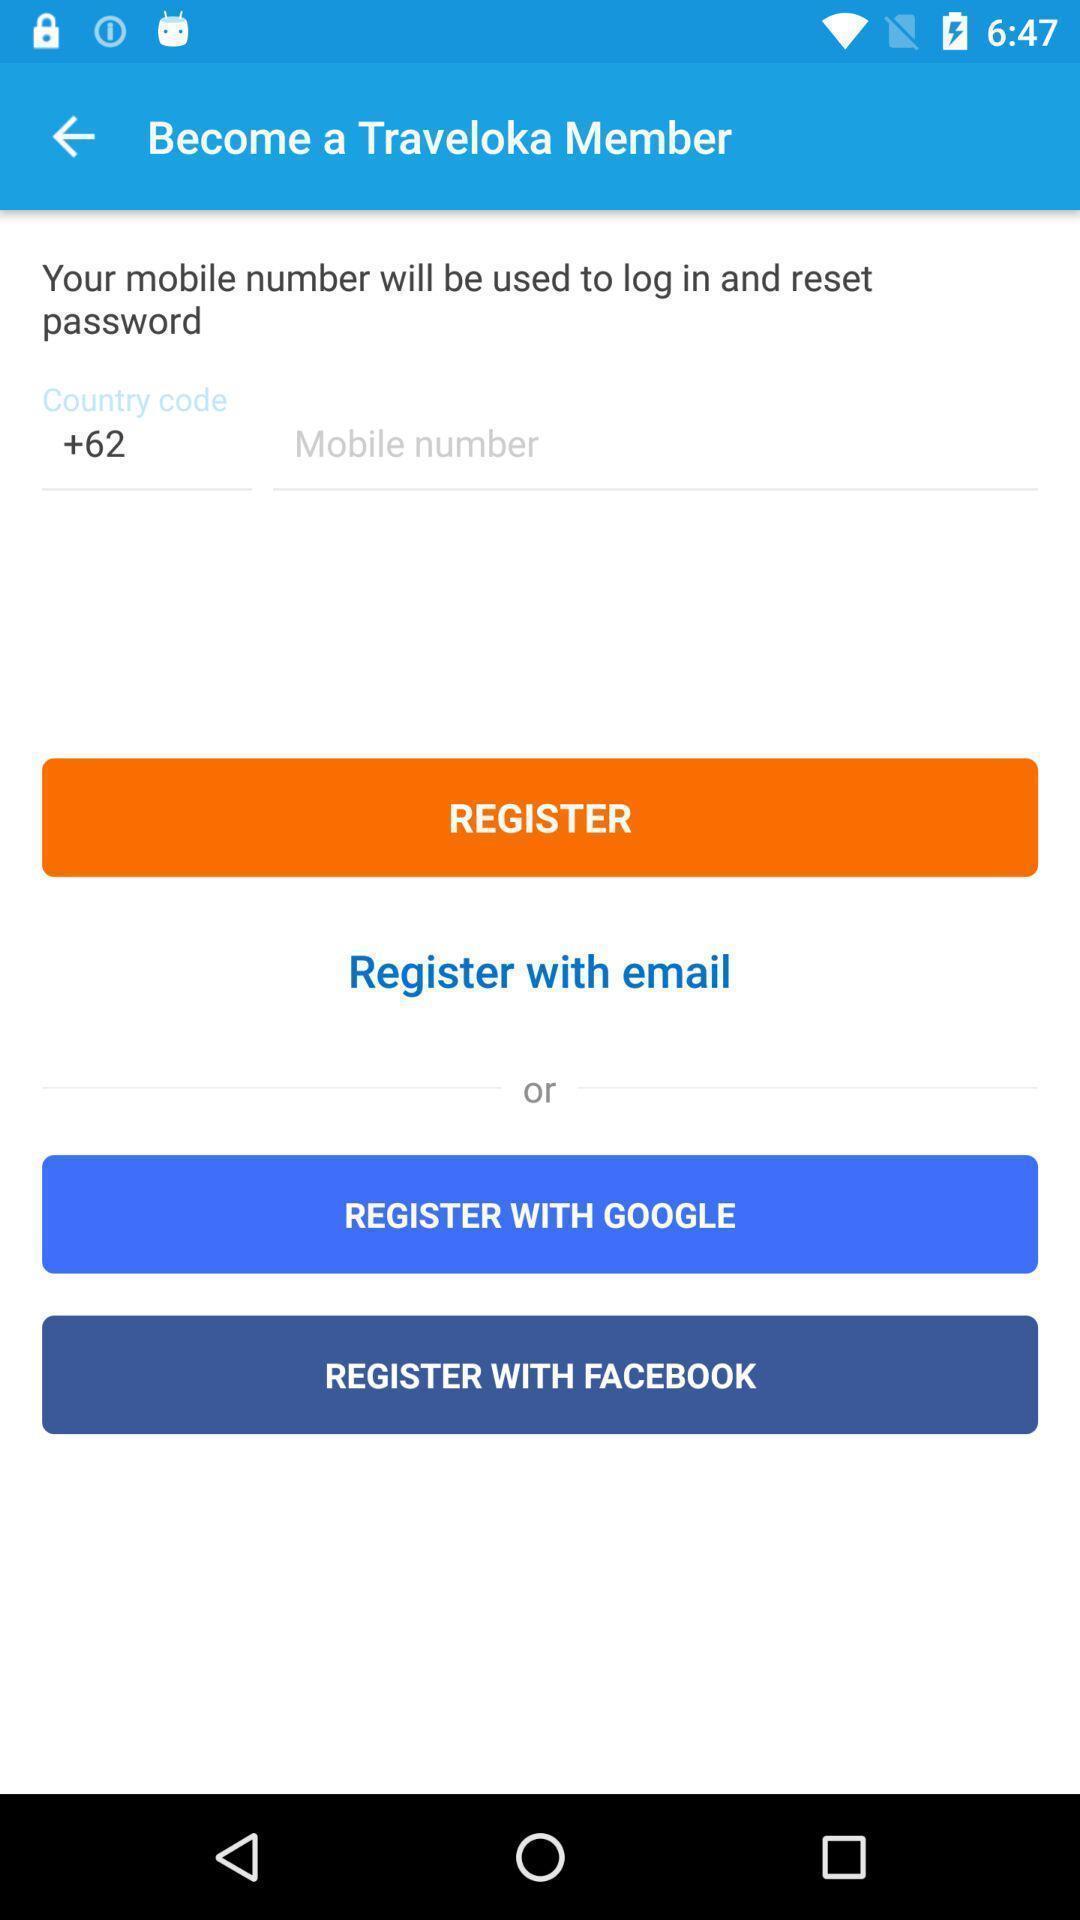Explain what's happening in this screen capture. Registration page in application to get access. 